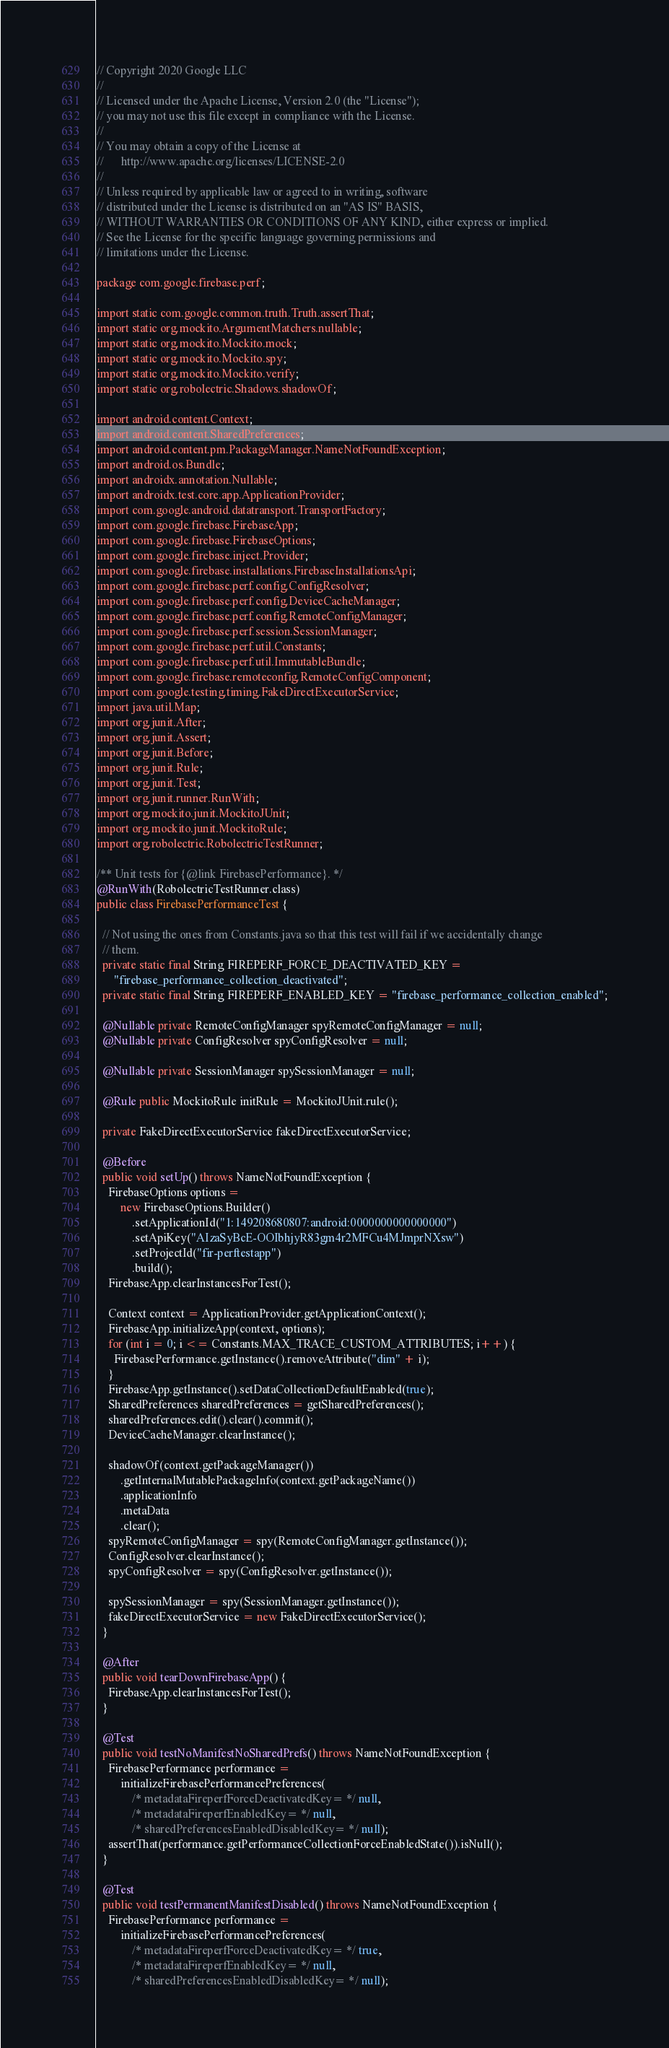Convert code to text. <code><loc_0><loc_0><loc_500><loc_500><_Java_>// Copyright 2020 Google LLC
//
// Licensed under the Apache License, Version 2.0 (the "License");
// you may not use this file except in compliance with the License.
//
// You may obtain a copy of the License at
//      http://www.apache.org/licenses/LICENSE-2.0
//
// Unless required by applicable law or agreed to in writing, software
// distributed under the License is distributed on an "AS IS" BASIS,
// WITHOUT WARRANTIES OR CONDITIONS OF ANY KIND, either express or implied.
// See the License for the specific language governing permissions and
// limitations under the License.

package com.google.firebase.perf;

import static com.google.common.truth.Truth.assertThat;
import static org.mockito.ArgumentMatchers.nullable;
import static org.mockito.Mockito.mock;
import static org.mockito.Mockito.spy;
import static org.mockito.Mockito.verify;
import static org.robolectric.Shadows.shadowOf;

import android.content.Context;
import android.content.SharedPreferences;
import android.content.pm.PackageManager.NameNotFoundException;
import android.os.Bundle;
import androidx.annotation.Nullable;
import androidx.test.core.app.ApplicationProvider;
import com.google.android.datatransport.TransportFactory;
import com.google.firebase.FirebaseApp;
import com.google.firebase.FirebaseOptions;
import com.google.firebase.inject.Provider;
import com.google.firebase.installations.FirebaseInstallationsApi;
import com.google.firebase.perf.config.ConfigResolver;
import com.google.firebase.perf.config.DeviceCacheManager;
import com.google.firebase.perf.config.RemoteConfigManager;
import com.google.firebase.perf.session.SessionManager;
import com.google.firebase.perf.util.Constants;
import com.google.firebase.perf.util.ImmutableBundle;
import com.google.firebase.remoteconfig.RemoteConfigComponent;
import com.google.testing.timing.FakeDirectExecutorService;
import java.util.Map;
import org.junit.After;
import org.junit.Assert;
import org.junit.Before;
import org.junit.Rule;
import org.junit.Test;
import org.junit.runner.RunWith;
import org.mockito.junit.MockitoJUnit;
import org.mockito.junit.MockitoRule;
import org.robolectric.RobolectricTestRunner;

/** Unit tests for {@link FirebasePerformance}. */
@RunWith(RobolectricTestRunner.class)
public class FirebasePerformanceTest {

  // Not using the ones from Constants.java so that this test will fail if we accidentally change
  // them.
  private static final String FIREPERF_FORCE_DEACTIVATED_KEY =
      "firebase_performance_collection_deactivated";
  private static final String FIREPERF_ENABLED_KEY = "firebase_performance_collection_enabled";

  @Nullable private RemoteConfigManager spyRemoteConfigManager = null;
  @Nullable private ConfigResolver spyConfigResolver = null;

  @Nullable private SessionManager spySessionManager = null;

  @Rule public MockitoRule initRule = MockitoJUnit.rule();

  private FakeDirectExecutorService fakeDirectExecutorService;

  @Before
  public void setUp() throws NameNotFoundException {
    FirebaseOptions options =
        new FirebaseOptions.Builder()
            .setApplicationId("1:149208680807:android:0000000000000000")
            .setApiKey("AIzaSyBcE-OOIbhjyR83gm4r2MFCu4MJmprNXsw")
            .setProjectId("fir-perftestapp")
            .build();
    FirebaseApp.clearInstancesForTest();

    Context context = ApplicationProvider.getApplicationContext();
    FirebaseApp.initializeApp(context, options);
    for (int i = 0; i <= Constants.MAX_TRACE_CUSTOM_ATTRIBUTES; i++) {
      FirebasePerformance.getInstance().removeAttribute("dim" + i);
    }
    FirebaseApp.getInstance().setDataCollectionDefaultEnabled(true);
    SharedPreferences sharedPreferences = getSharedPreferences();
    sharedPreferences.edit().clear().commit();
    DeviceCacheManager.clearInstance();

    shadowOf(context.getPackageManager())
        .getInternalMutablePackageInfo(context.getPackageName())
        .applicationInfo
        .metaData
        .clear();
    spyRemoteConfigManager = spy(RemoteConfigManager.getInstance());
    ConfigResolver.clearInstance();
    spyConfigResolver = spy(ConfigResolver.getInstance());

    spySessionManager = spy(SessionManager.getInstance());
    fakeDirectExecutorService = new FakeDirectExecutorService();
  }

  @After
  public void tearDownFirebaseApp() {
    FirebaseApp.clearInstancesForTest();
  }

  @Test
  public void testNoManifestNoSharedPrefs() throws NameNotFoundException {
    FirebasePerformance performance =
        initializeFirebasePerformancePreferences(
            /* metadataFireperfForceDeactivatedKey= */ null,
            /* metadataFireperfEnabledKey= */ null,
            /* sharedPreferencesEnabledDisabledKey= */ null);
    assertThat(performance.getPerformanceCollectionForceEnabledState()).isNull();
  }

  @Test
  public void testPermanentManifestDisabled() throws NameNotFoundException {
    FirebasePerformance performance =
        initializeFirebasePerformancePreferences(
            /* metadataFireperfForceDeactivatedKey= */ true,
            /* metadataFireperfEnabledKey= */ null,
            /* sharedPreferencesEnabledDisabledKey= */ null);</code> 